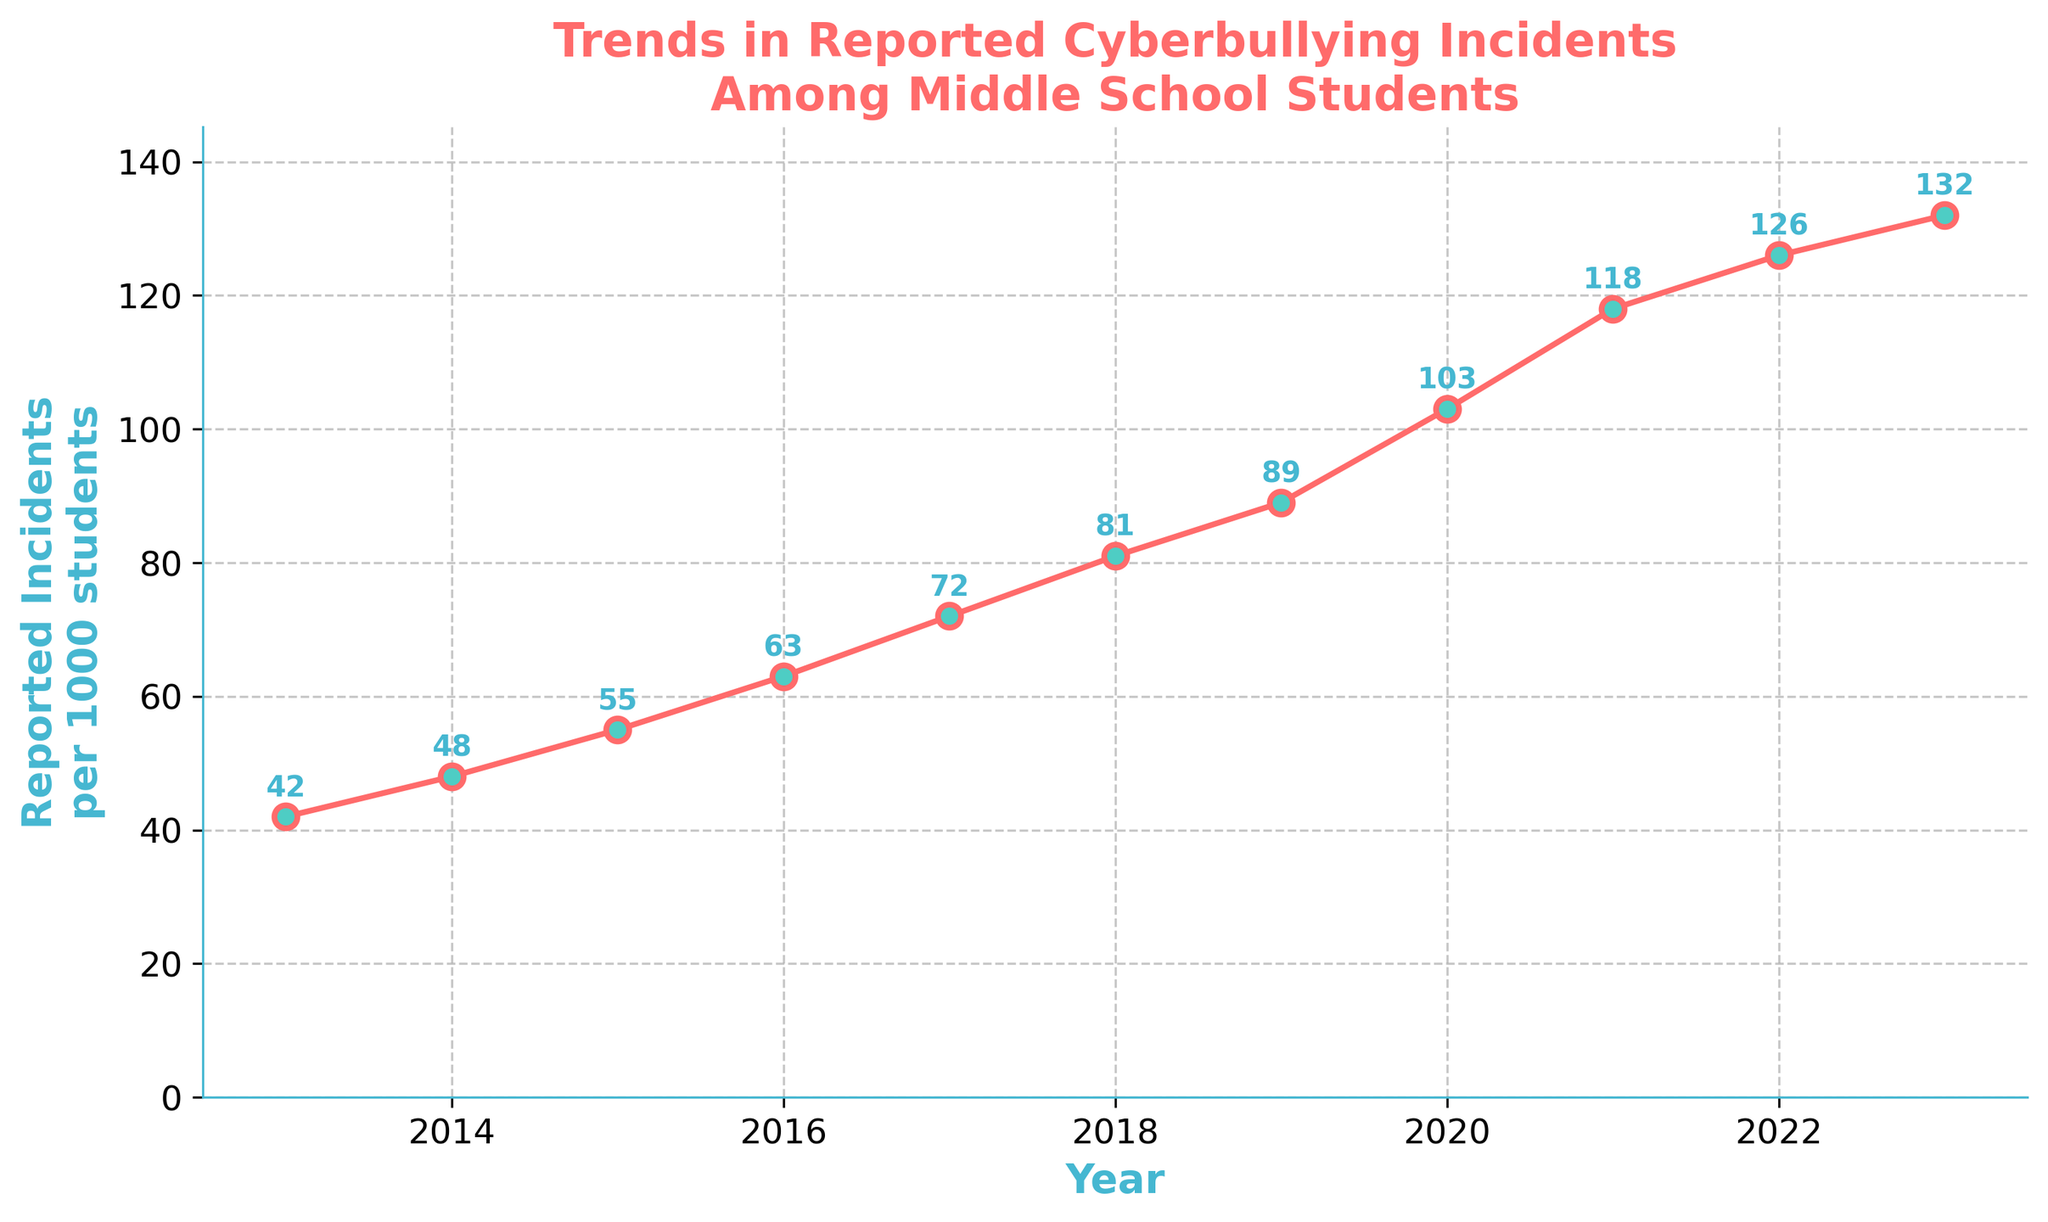What year had the highest number of reported cyberbullying incidents? From the figure, the year with the highest point on the line is 2023. This indicates the most reported incidents.
Answer: 2023 Which year saw the newest decrease in reported incidents compared to the previous year? Looking at the trends in the figure, every year shows an increase in reported incidents compared to the previous year, so there were no decreases.
Answer: No year Between which years did the incidents increase the most? To find this, compare the differences year over year. The largest change occurred from 2019 (89) to 2020 (103); the increase is 14 incidents.
Answer: 2019 to 2020 What is the average number of reported incidents for the years 2021 to 2023? Add the incidents for 2021 (118), 2022 (126), and 2023 (132) and then divide by 3. The sum is 118 + 126 + 132 = 376. The average is 376/3 ≈ 125.33
Answer: 125.33 What is the overall trend in reported cyberbullying incidents from 2013 to 2023? The line in the figure shows a consistent upward trend, indicating an increase in reported incidents over the entire period.
Answer: Increasing How much did the number of reported incidents increase from 2013 to 2023? Subtract the value in 2013 (42) from the value in 2023 (132). 132 - 42 = 90
Answer: 90 During which period did the incidents surpass 100 per 1000 students? By looking at the line, the incidents surpassed 100 between 2019 (89) and 2020 (103).
Answer: 2019 to 2020 What is the rate of increase in reported incidents per year on average from 2013 to 2023? First, find the total increase from 2013 to 2023, which is 132 - 42 = 90. Then divide by the number of years (10). The rate of increase is 90/10 = 9 incidents per year.
Answer: 9 per year What is the visual difference in the line's steepness between the periods 2013-2015 and 2021-2023? The line from 2013-2015 is less steep compared to 2021-2023. This suggests that the rate of increase was slower in the earlier period and faster in the recent period.
Answer: Steepness increased In which year did the reported incidents nearly double compared to 2013? Doubling 2013's number (42) gives 84. The year closest to this number is 2019, which recorded 89 incidents.
Answer: 2019 